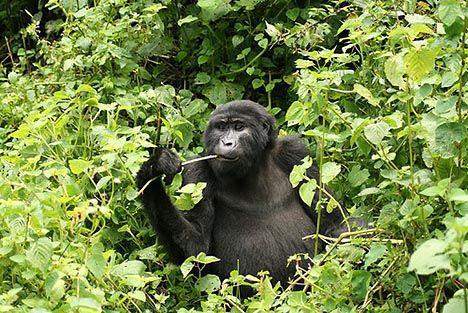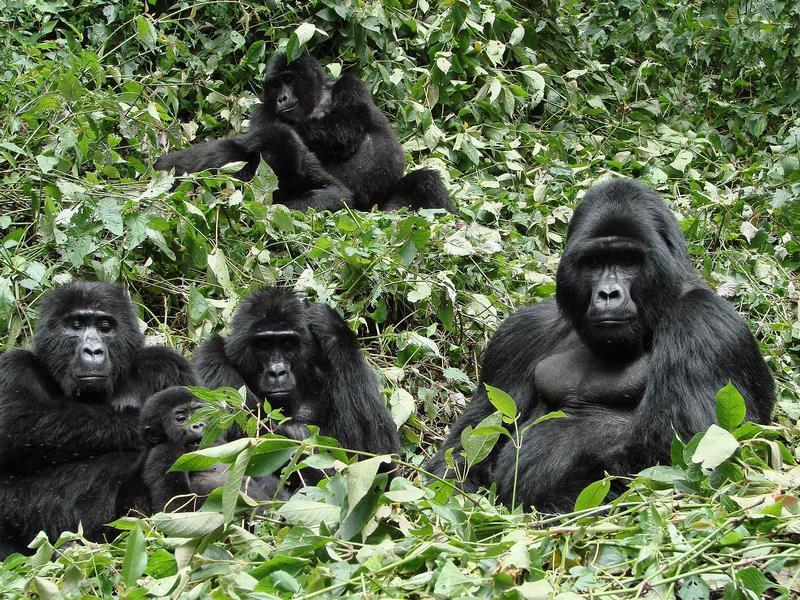The first image is the image on the left, the second image is the image on the right. Assess this claim about the two images: "The right image contains no more than two gorillas.". Correct or not? Answer yes or no. No. The first image is the image on the left, the second image is the image on the right. Assess this claim about the two images: "In at least one image there is a baby gorilla trying to hold onto the back of a large gorilla.". Correct or not? Answer yes or no. No. 